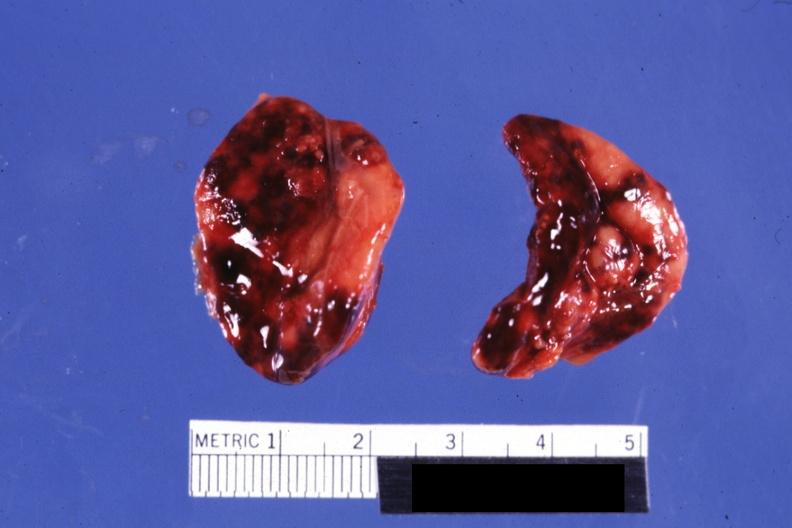what is present?
Answer the question using a single word or phrase. Endocrine 